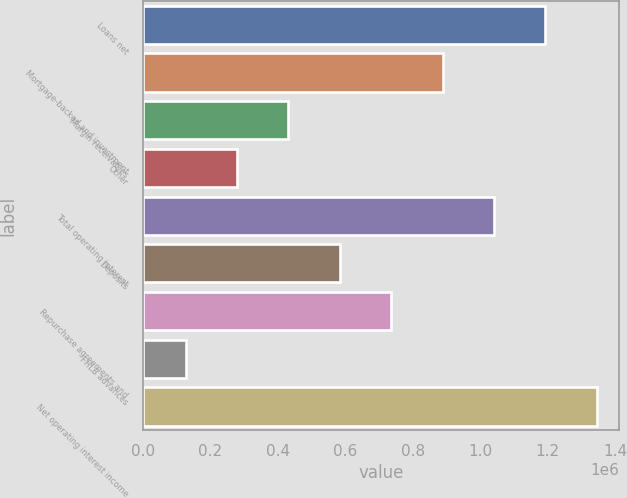Convert chart to OTSL. <chart><loc_0><loc_0><loc_500><loc_500><bar_chart><fcel>Loans net<fcel>Mortgage-backed and investment<fcel>Margin receivables<fcel>Other<fcel>Total operating interest<fcel>Deposits<fcel>Repurchase agreements and<fcel>FHLB advances<fcel>Net operating interest income<nl><fcel>1.19313e+06<fcel>888380<fcel>431249<fcel>278872<fcel>1.04076e+06<fcel>583626<fcel>736003<fcel>126495<fcel>1.34551e+06<nl></chart> 